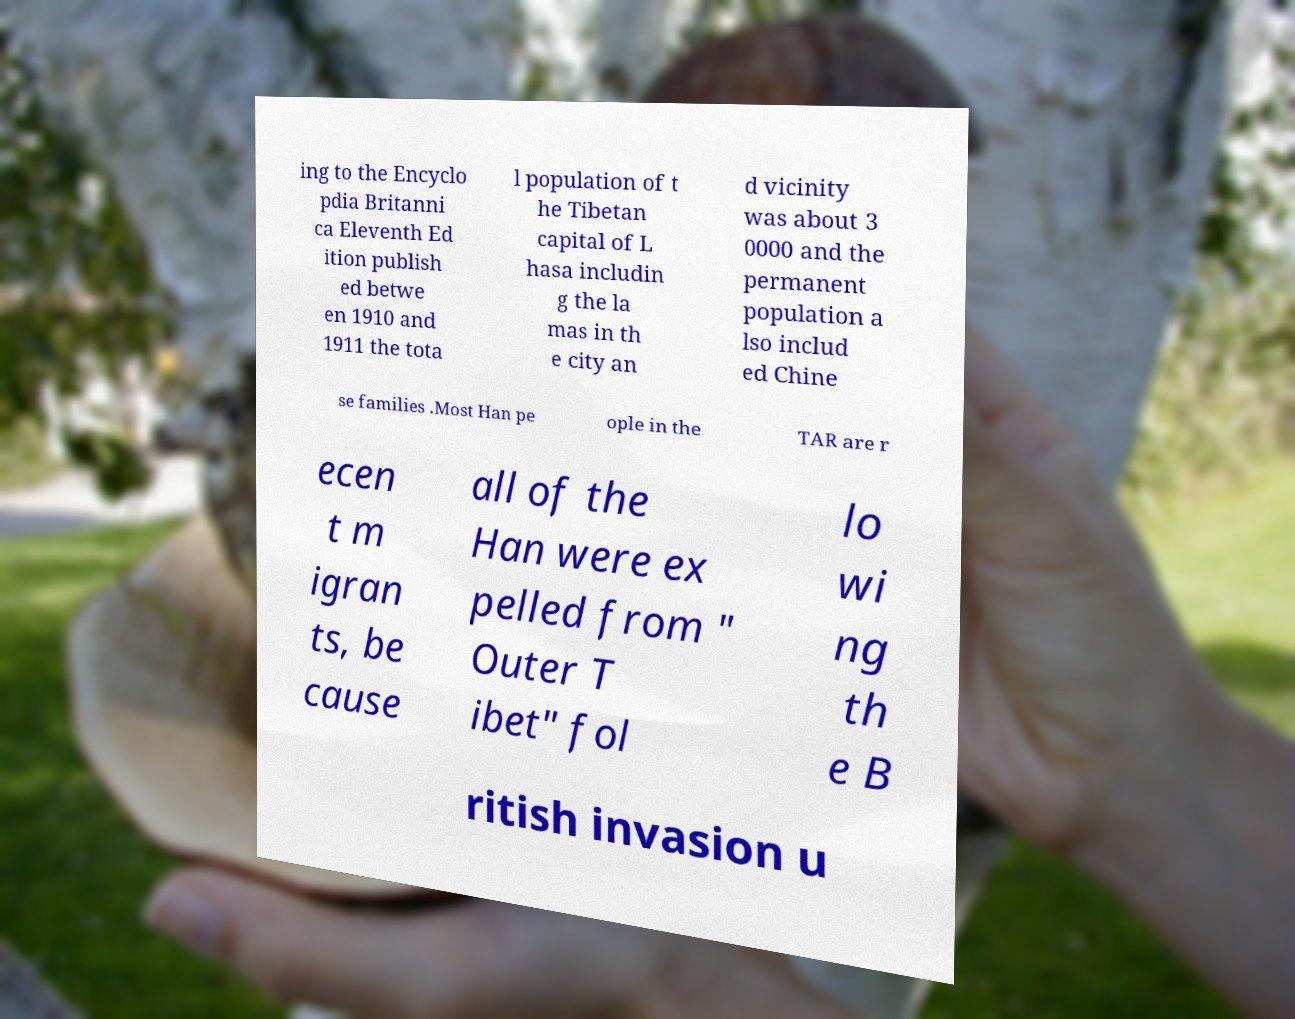Can you read and provide the text displayed in the image?This photo seems to have some interesting text. Can you extract and type it out for me? ing to the Encyclo pdia Britanni ca Eleventh Ed ition publish ed betwe en 1910 and 1911 the tota l population of t he Tibetan capital of L hasa includin g the la mas in th e city an d vicinity was about 3 0000 and the permanent population a lso includ ed Chine se families .Most Han pe ople in the TAR are r ecen t m igran ts, be cause all of the Han were ex pelled from " Outer T ibet" fol lo wi ng th e B ritish invasion u 